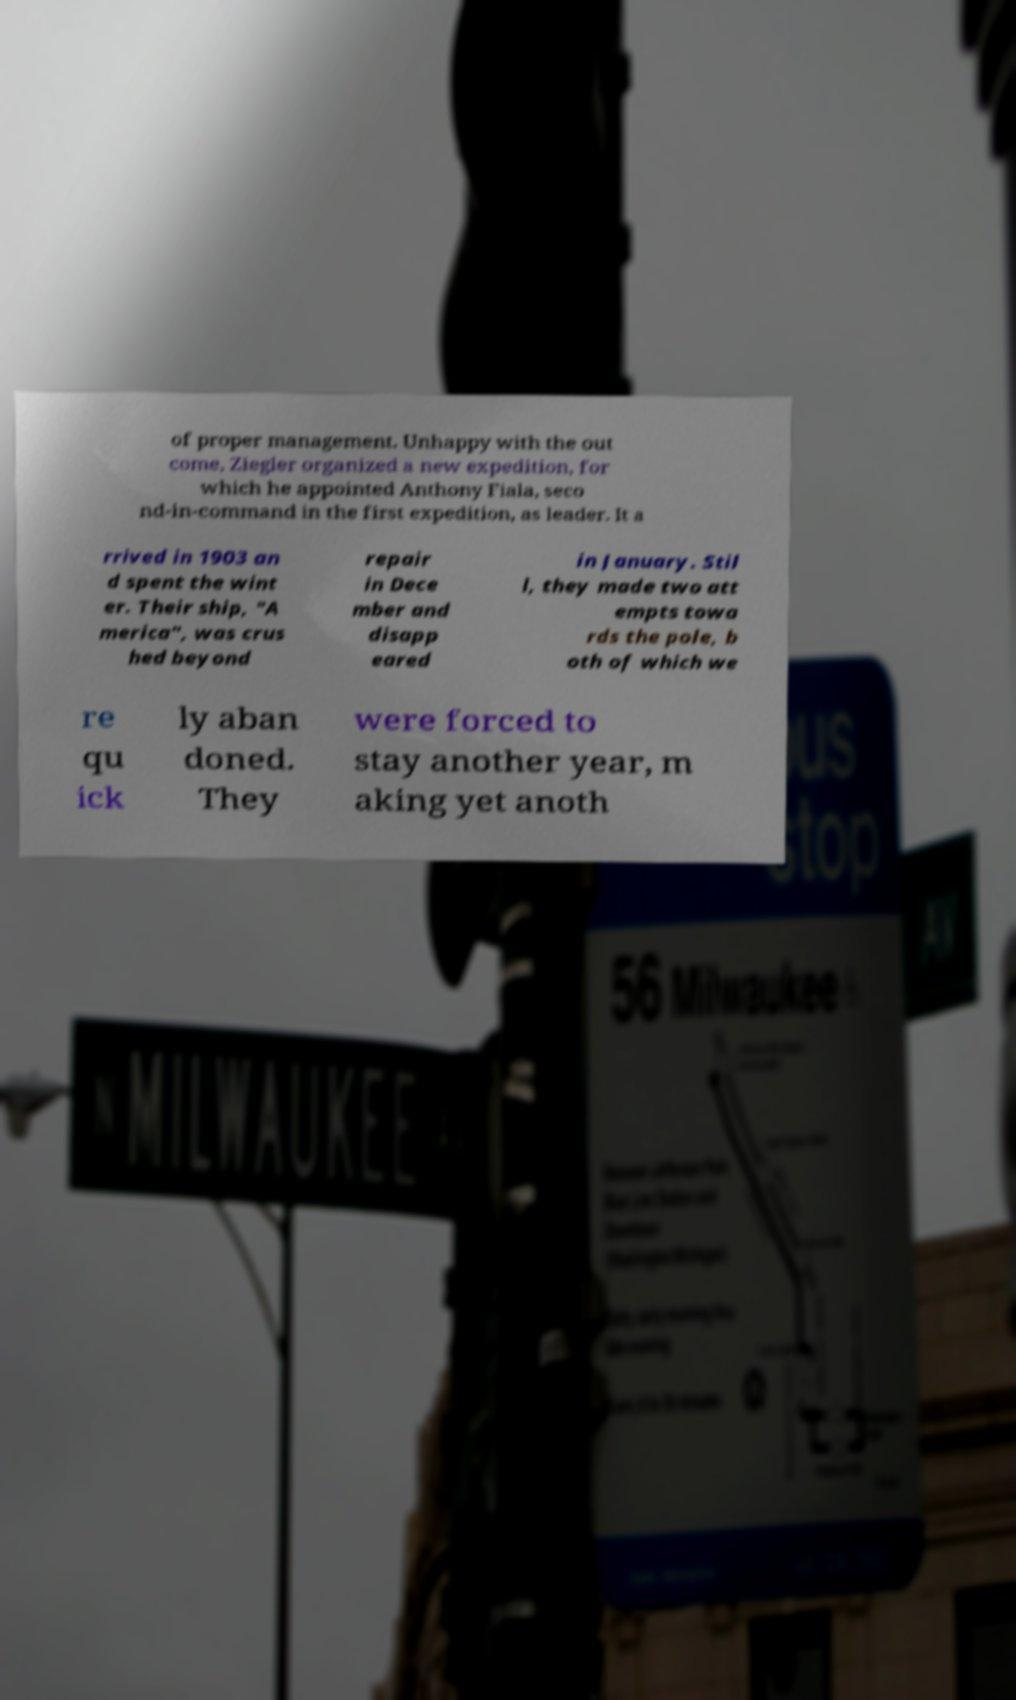Could you extract and type out the text from this image? of proper management. Unhappy with the out come, Ziegler organized a new expedition, for which he appointed Anthony Fiala, seco nd-in-command in the first expedition, as leader. It a rrived in 1903 an d spent the wint er. Their ship, "A merica", was crus hed beyond repair in Dece mber and disapp eared in January. Stil l, they made two att empts towa rds the pole, b oth of which we re qu ick ly aban doned. They were forced to stay another year, m aking yet anoth 